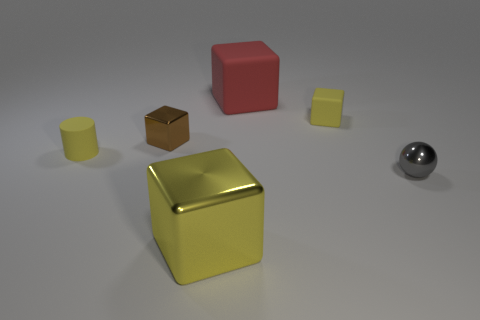Add 3 small brown metal objects. How many objects exist? 9 Subtract all blocks. How many objects are left? 2 Subtract 0 red spheres. How many objects are left? 6 Subtract all tiny rubber balls. Subtract all big yellow shiny objects. How many objects are left? 5 Add 4 red matte blocks. How many red matte blocks are left? 5 Add 4 yellow things. How many yellow things exist? 7 